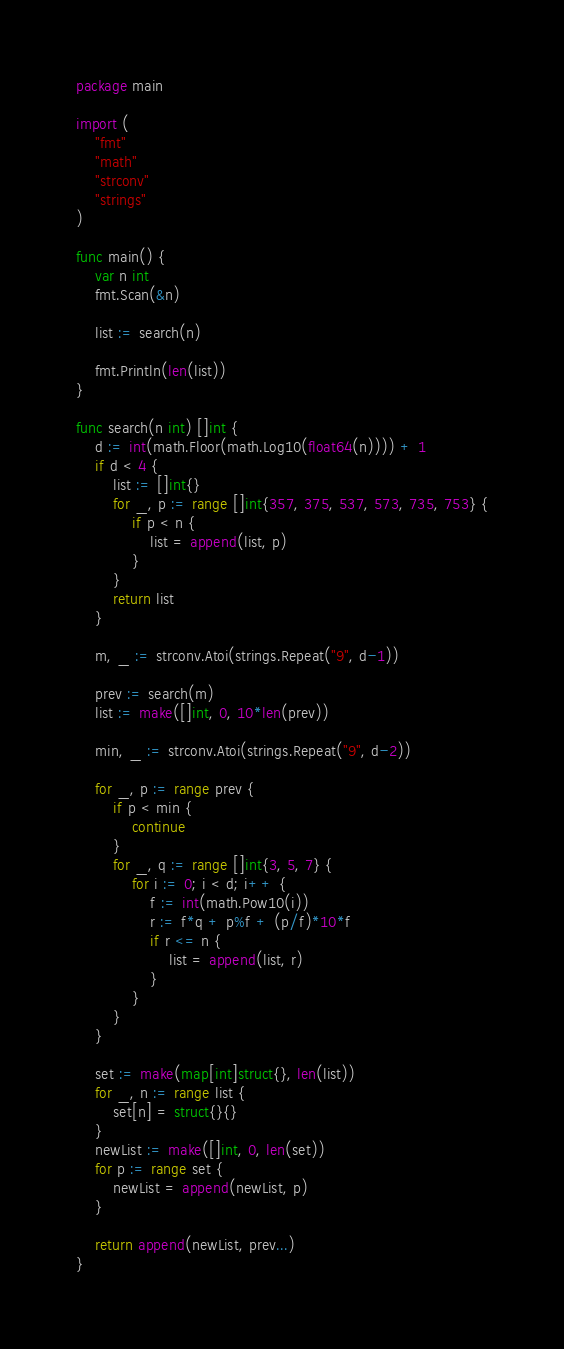Convert code to text. <code><loc_0><loc_0><loc_500><loc_500><_Go_>package main

import (
	"fmt"
	"math"
	"strconv"
	"strings"
)

func main() {
	var n int
	fmt.Scan(&n)

	list := search(n)

	fmt.Println(len(list))
}

func search(n int) []int {
	d := int(math.Floor(math.Log10(float64(n)))) + 1
	if d < 4 {
		list := []int{}
		for _, p := range []int{357, 375, 537, 573, 735, 753} {
			if p < n {
				list = append(list, p)
			}
		}
		return list
	}

	m, _ := strconv.Atoi(strings.Repeat("9", d-1))

	prev := search(m)
	list := make([]int, 0, 10*len(prev))

	min, _ := strconv.Atoi(strings.Repeat("9", d-2))

	for _, p := range prev {
		if p < min {
			continue
		}
		for _, q := range []int{3, 5, 7} {
			for i := 0; i < d; i++ {
				f := int(math.Pow10(i))
				r := f*q + p%f + (p/f)*10*f
				if r <= n {
					list = append(list, r)
				}
			}
		}
	}

	set := make(map[int]struct{}, len(list))
	for _, n := range list {
		set[n] = struct{}{}
	}
	newList := make([]int, 0, len(set))
	for p := range set {
		newList = append(newList, p)
	}

	return append(newList, prev...)
}
</code> 